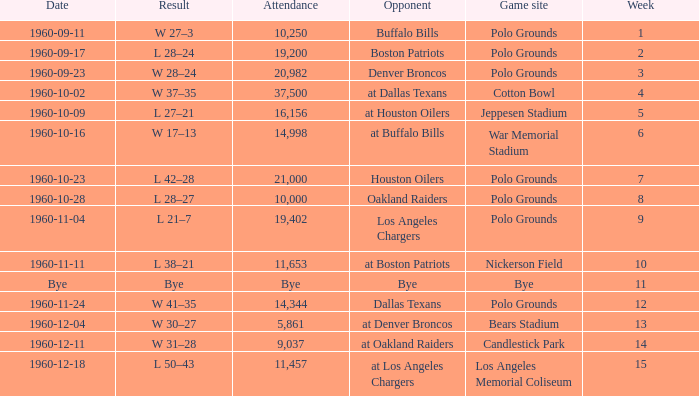What day had 37,500 attending? 1960-10-02. 